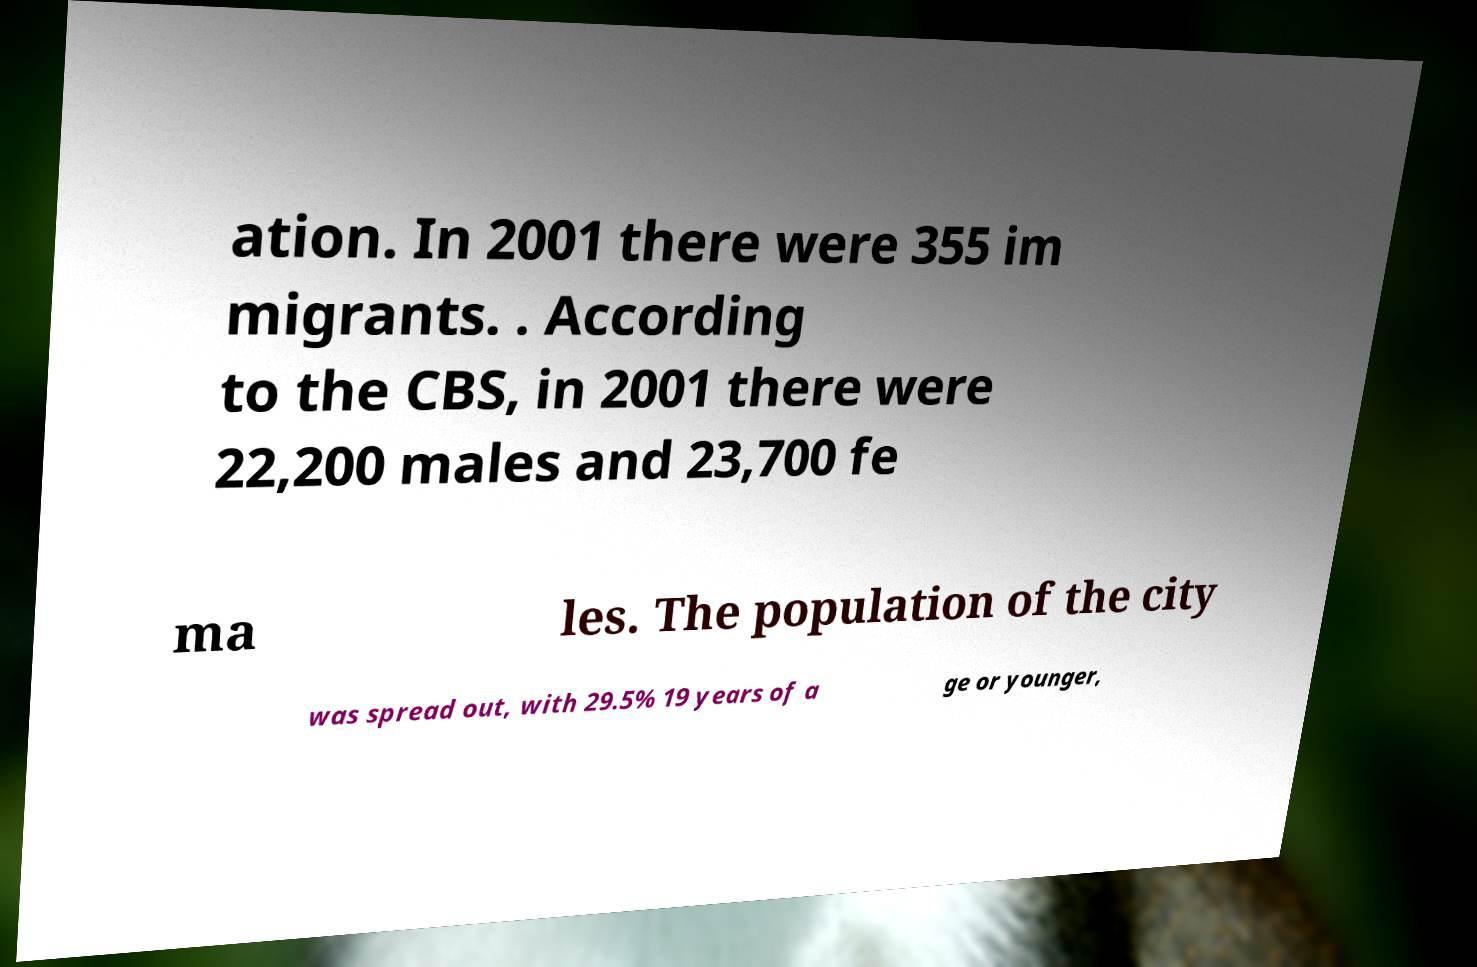There's text embedded in this image that I need extracted. Can you transcribe it verbatim? ation. In 2001 there were 355 im migrants. . According to the CBS, in 2001 there were 22,200 males and 23,700 fe ma les. The population of the city was spread out, with 29.5% 19 years of a ge or younger, 